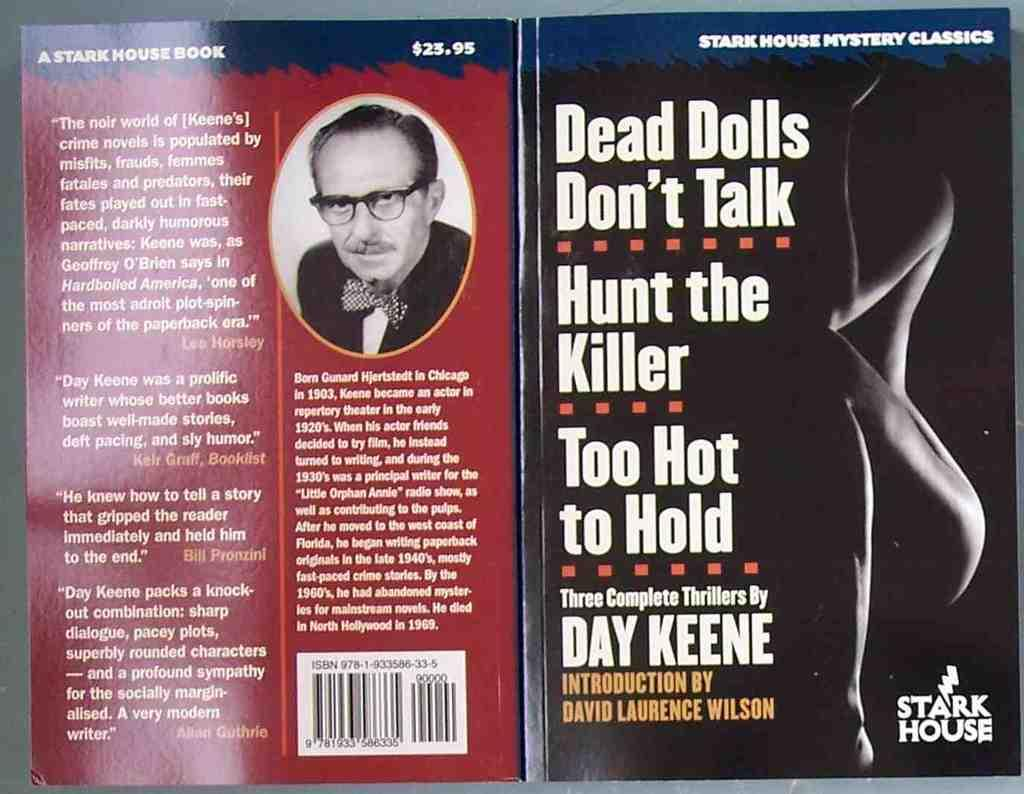<image>
Render a clear and concise summary of the photo. A book by Day Keene has a picture of the author on the back cover. 